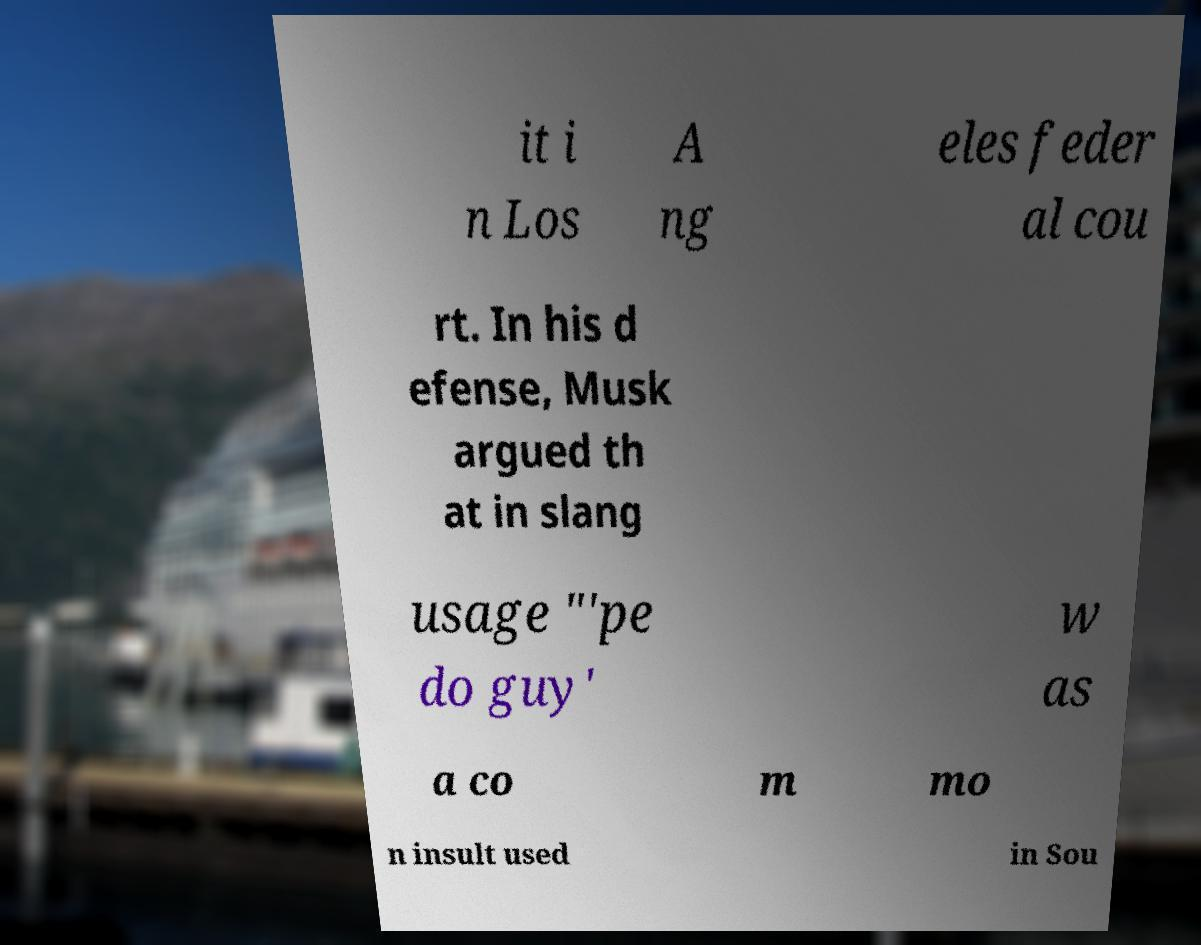I need the written content from this picture converted into text. Can you do that? it i n Los A ng eles feder al cou rt. In his d efense, Musk argued th at in slang usage "'pe do guy' w as a co m mo n insult used in Sou 